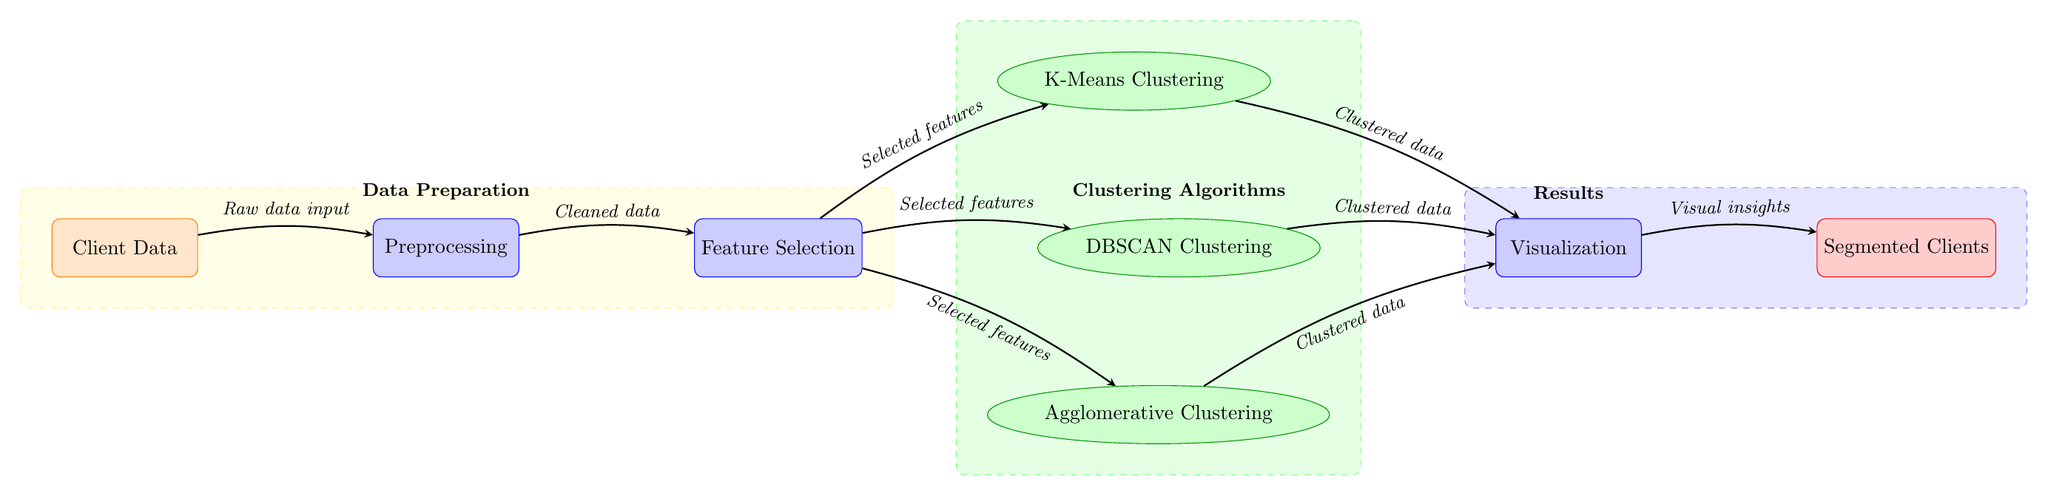What is the first node in the diagram? The first node in the diagram is labeled "Client Data." It is the starting point for the flow of information in the diagram, representing the input data.
Answer: Client Data How many clustering algorithms are represented in the diagram? The diagram includes three clustering algorithms: K-Means Clustering, DBSCAN Clustering, and Agglomerative Clustering. They are distinctly represented as ellipses above and below the feature selection node.
Answer: Three What is the output of the diagram? The final output of the diagram is labeled "Segmented Clients," which represents the result of the preceding processes that segmented the client data after clustering.
Answer: Segmented Clients What type of process happens after feature selection? After feature selection, the clustering algorithms (K-Means, DBSCAN, and Agglomerative Clustering) are applied to the selected features to categorize the client data into segments.
Answer: Clustering algorithms Which node represents preprocessing? The node that represents preprocessing is directly after the "Client Data" node. It is labeled "Preprocessing," indicating that this step involves cleaning and preparing the data for analysis.
Answer: Preprocessing How is the flow of data represented between nodes? The flow of data is represented by arrows connecting the nodes, showing the direction and sequence in which the processes occur from input to output. Each arrow is labeled with descriptions of the data being passed.
Answer: Arrows Which process immediately follows data cleaning? The process that immediately follows data cleaning is feature selection, which involves determining the most relevant attributes from the cleaned data for clustering purposes.
Answer: Feature Selection What are the colors used for the different types of nodes? The colors used in the diagram are as follows: orange for data source, blue for processes, green for algorithms, and red for output. This color coding helps differentiate the types of nodes at a glance.
Answer: Orange, blue, green, red Which background area encloses the clustering algorithms? The clustering algorithms are enclosed in a green dashed background area labeled "Clustering Algorithms," indicating that this section is dedicated to the methodologies used for grouping client data.
Answer: Clustering Algorithms 